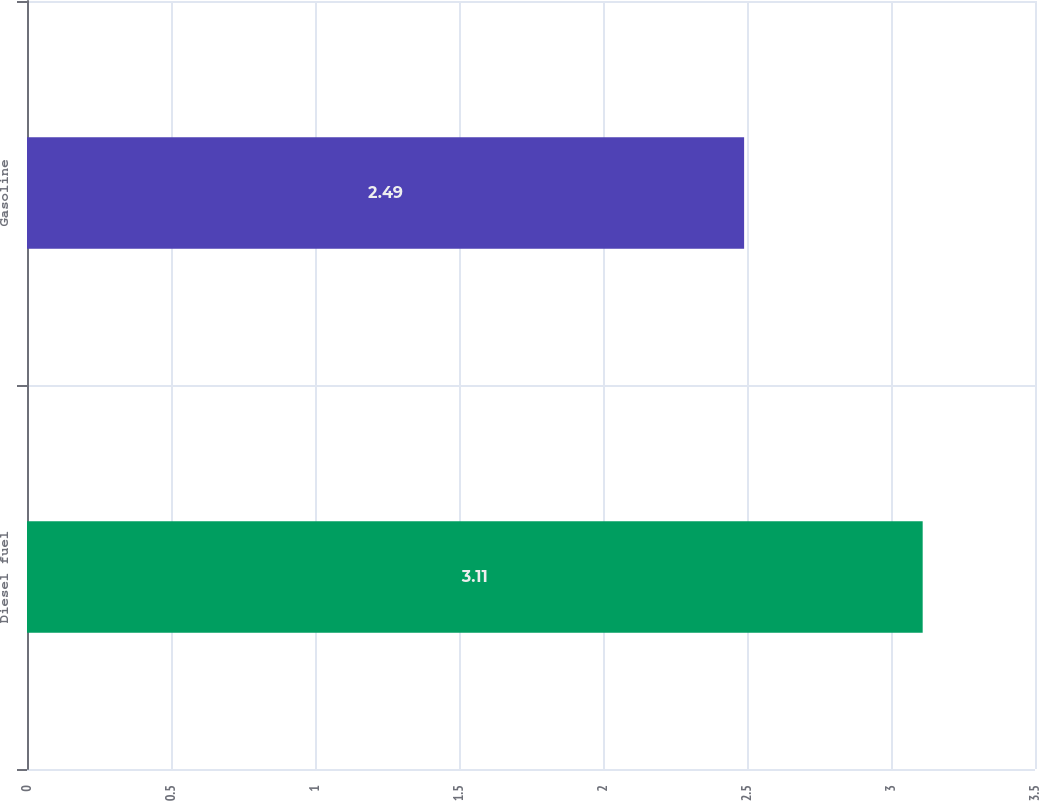<chart> <loc_0><loc_0><loc_500><loc_500><bar_chart><fcel>Diesel fuel<fcel>Gasoline<nl><fcel>3.11<fcel>2.49<nl></chart> 